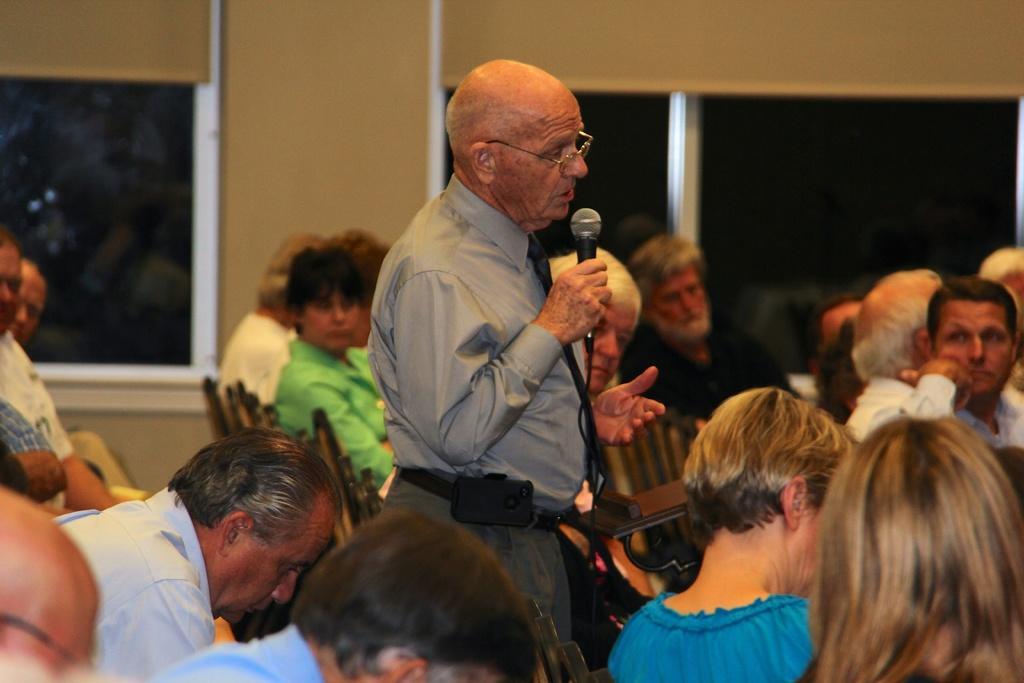Could you give a brief overview of what you see in this image? In this picture we can see person standing in middle holding mic in his hand and talking and remaining persons are sitting on chair and listening to him and in background we can see wall. 